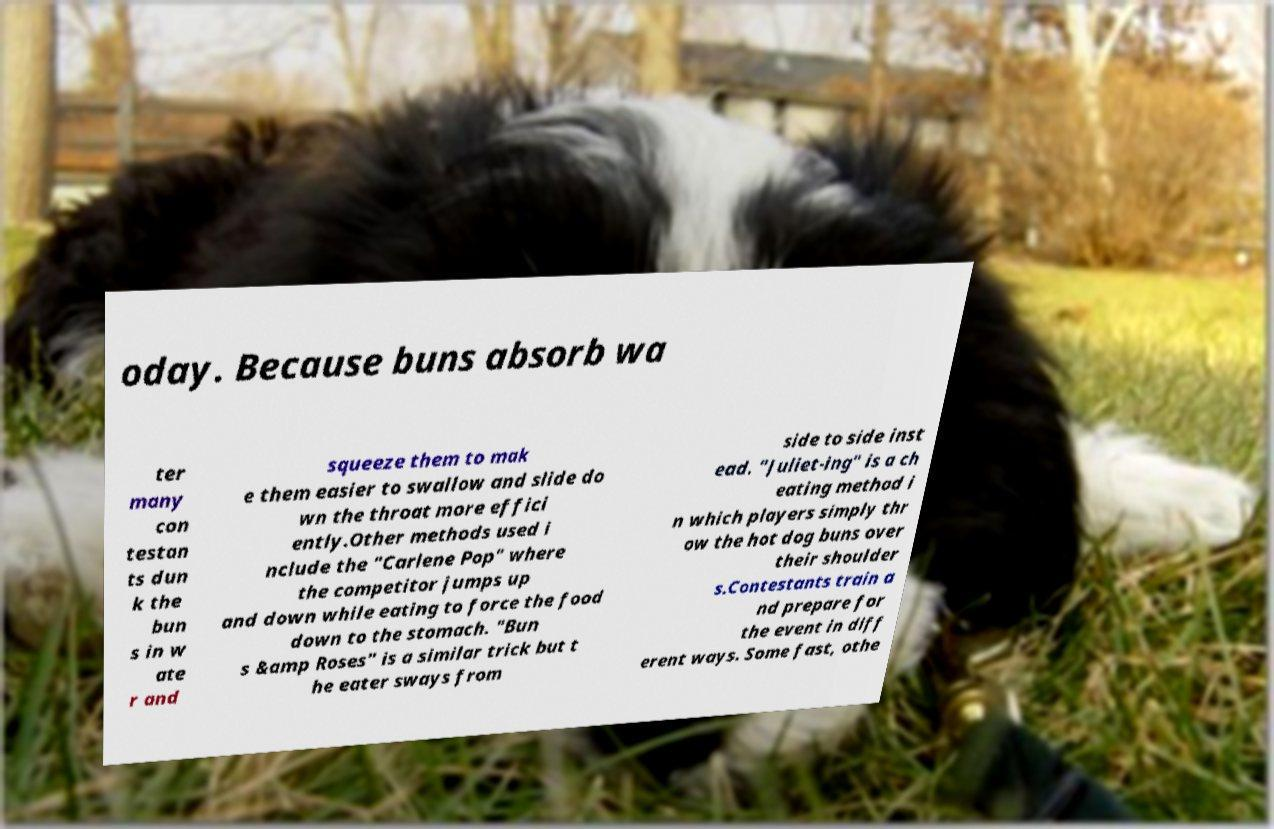For documentation purposes, I need the text within this image transcribed. Could you provide that? oday. Because buns absorb wa ter many con testan ts dun k the bun s in w ate r and squeeze them to mak e them easier to swallow and slide do wn the throat more effici ently.Other methods used i nclude the "Carlene Pop" where the competitor jumps up and down while eating to force the food down to the stomach. "Bun s &amp Roses" is a similar trick but t he eater sways from side to side inst ead. "Juliet-ing" is a ch eating method i n which players simply thr ow the hot dog buns over their shoulder s.Contestants train a nd prepare for the event in diff erent ways. Some fast, othe 